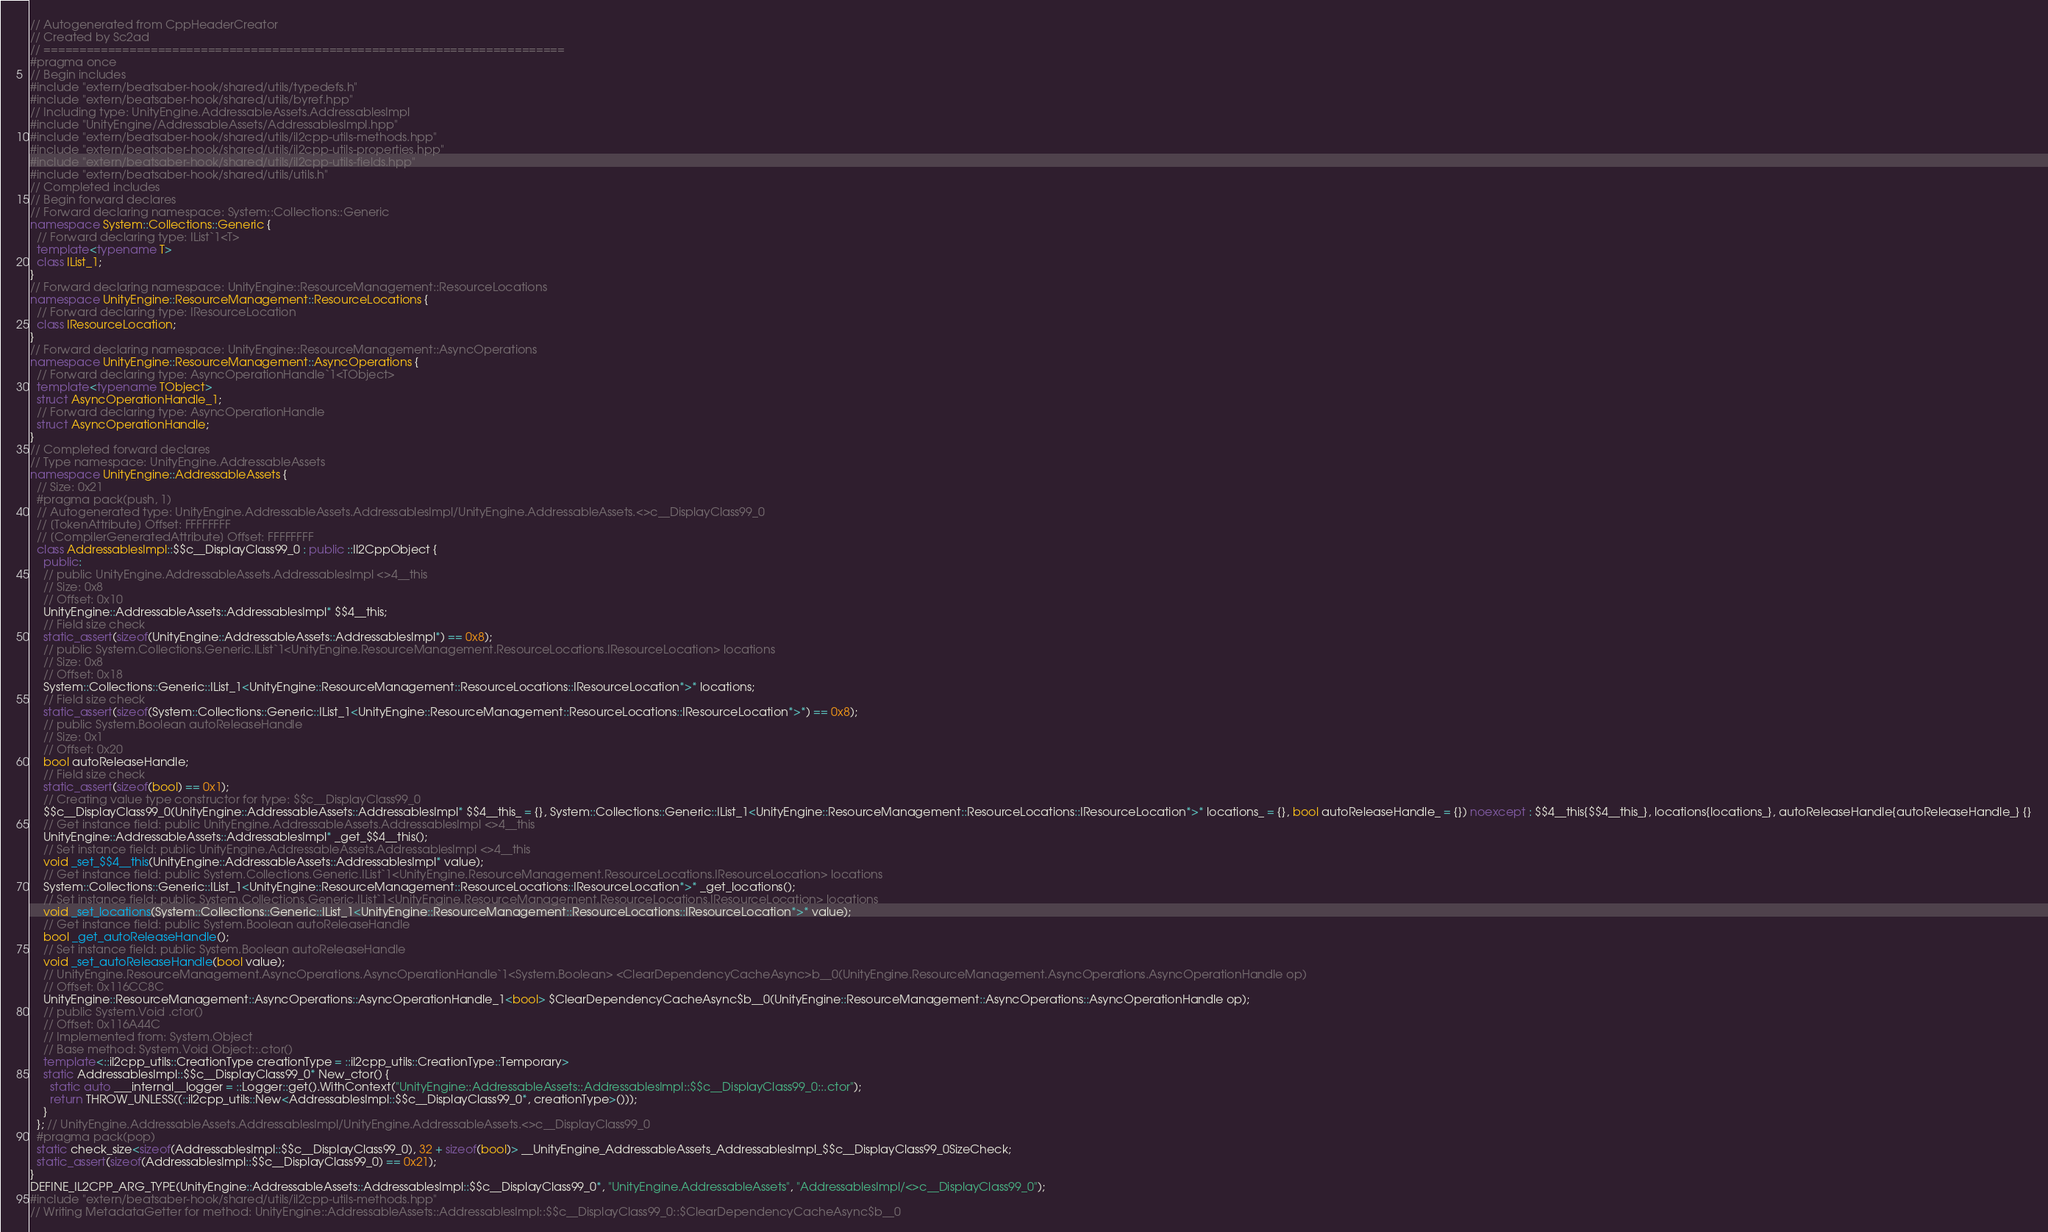Convert code to text. <code><loc_0><loc_0><loc_500><loc_500><_C++_>// Autogenerated from CppHeaderCreator
// Created by Sc2ad
// =========================================================================
#pragma once
// Begin includes
#include "extern/beatsaber-hook/shared/utils/typedefs.h"
#include "extern/beatsaber-hook/shared/utils/byref.hpp"
// Including type: UnityEngine.AddressableAssets.AddressablesImpl
#include "UnityEngine/AddressableAssets/AddressablesImpl.hpp"
#include "extern/beatsaber-hook/shared/utils/il2cpp-utils-methods.hpp"
#include "extern/beatsaber-hook/shared/utils/il2cpp-utils-properties.hpp"
#include "extern/beatsaber-hook/shared/utils/il2cpp-utils-fields.hpp"
#include "extern/beatsaber-hook/shared/utils/utils.h"
// Completed includes
// Begin forward declares
// Forward declaring namespace: System::Collections::Generic
namespace System::Collections::Generic {
  // Forward declaring type: IList`1<T>
  template<typename T>
  class IList_1;
}
// Forward declaring namespace: UnityEngine::ResourceManagement::ResourceLocations
namespace UnityEngine::ResourceManagement::ResourceLocations {
  // Forward declaring type: IResourceLocation
  class IResourceLocation;
}
// Forward declaring namespace: UnityEngine::ResourceManagement::AsyncOperations
namespace UnityEngine::ResourceManagement::AsyncOperations {
  // Forward declaring type: AsyncOperationHandle`1<TObject>
  template<typename TObject>
  struct AsyncOperationHandle_1;
  // Forward declaring type: AsyncOperationHandle
  struct AsyncOperationHandle;
}
// Completed forward declares
// Type namespace: UnityEngine.AddressableAssets
namespace UnityEngine::AddressableAssets {
  // Size: 0x21
  #pragma pack(push, 1)
  // Autogenerated type: UnityEngine.AddressableAssets.AddressablesImpl/UnityEngine.AddressableAssets.<>c__DisplayClass99_0
  // [TokenAttribute] Offset: FFFFFFFF
  // [CompilerGeneratedAttribute] Offset: FFFFFFFF
  class AddressablesImpl::$$c__DisplayClass99_0 : public ::Il2CppObject {
    public:
    // public UnityEngine.AddressableAssets.AddressablesImpl <>4__this
    // Size: 0x8
    // Offset: 0x10
    UnityEngine::AddressableAssets::AddressablesImpl* $$4__this;
    // Field size check
    static_assert(sizeof(UnityEngine::AddressableAssets::AddressablesImpl*) == 0x8);
    // public System.Collections.Generic.IList`1<UnityEngine.ResourceManagement.ResourceLocations.IResourceLocation> locations
    // Size: 0x8
    // Offset: 0x18
    System::Collections::Generic::IList_1<UnityEngine::ResourceManagement::ResourceLocations::IResourceLocation*>* locations;
    // Field size check
    static_assert(sizeof(System::Collections::Generic::IList_1<UnityEngine::ResourceManagement::ResourceLocations::IResourceLocation*>*) == 0x8);
    // public System.Boolean autoReleaseHandle
    // Size: 0x1
    // Offset: 0x20
    bool autoReleaseHandle;
    // Field size check
    static_assert(sizeof(bool) == 0x1);
    // Creating value type constructor for type: $$c__DisplayClass99_0
    $$c__DisplayClass99_0(UnityEngine::AddressableAssets::AddressablesImpl* $$4__this_ = {}, System::Collections::Generic::IList_1<UnityEngine::ResourceManagement::ResourceLocations::IResourceLocation*>* locations_ = {}, bool autoReleaseHandle_ = {}) noexcept : $$4__this{$$4__this_}, locations{locations_}, autoReleaseHandle{autoReleaseHandle_} {}
    // Get instance field: public UnityEngine.AddressableAssets.AddressablesImpl <>4__this
    UnityEngine::AddressableAssets::AddressablesImpl* _get_$$4__this();
    // Set instance field: public UnityEngine.AddressableAssets.AddressablesImpl <>4__this
    void _set_$$4__this(UnityEngine::AddressableAssets::AddressablesImpl* value);
    // Get instance field: public System.Collections.Generic.IList`1<UnityEngine.ResourceManagement.ResourceLocations.IResourceLocation> locations
    System::Collections::Generic::IList_1<UnityEngine::ResourceManagement::ResourceLocations::IResourceLocation*>* _get_locations();
    // Set instance field: public System.Collections.Generic.IList`1<UnityEngine.ResourceManagement.ResourceLocations.IResourceLocation> locations
    void _set_locations(System::Collections::Generic::IList_1<UnityEngine::ResourceManagement::ResourceLocations::IResourceLocation*>* value);
    // Get instance field: public System.Boolean autoReleaseHandle
    bool _get_autoReleaseHandle();
    // Set instance field: public System.Boolean autoReleaseHandle
    void _set_autoReleaseHandle(bool value);
    // UnityEngine.ResourceManagement.AsyncOperations.AsyncOperationHandle`1<System.Boolean> <ClearDependencyCacheAsync>b__0(UnityEngine.ResourceManagement.AsyncOperations.AsyncOperationHandle op)
    // Offset: 0x116CC8C
    UnityEngine::ResourceManagement::AsyncOperations::AsyncOperationHandle_1<bool> $ClearDependencyCacheAsync$b__0(UnityEngine::ResourceManagement::AsyncOperations::AsyncOperationHandle op);
    // public System.Void .ctor()
    // Offset: 0x116A44C
    // Implemented from: System.Object
    // Base method: System.Void Object::.ctor()
    template<::il2cpp_utils::CreationType creationType = ::il2cpp_utils::CreationType::Temporary>
    static AddressablesImpl::$$c__DisplayClass99_0* New_ctor() {
      static auto ___internal__logger = ::Logger::get().WithContext("UnityEngine::AddressableAssets::AddressablesImpl::$$c__DisplayClass99_0::.ctor");
      return THROW_UNLESS((::il2cpp_utils::New<AddressablesImpl::$$c__DisplayClass99_0*, creationType>()));
    }
  }; // UnityEngine.AddressableAssets.AddressablesImpl/UnityEngine.AddressableAssets.<>c__DisplayClass99_0
  #pragma pack(pop)
  static check_size<sizeof(AddressablesImpl::$$c__DisplayClass99_0), 32 + sizeof(bool)> __UnityEngine_AddressableAssets_AddressablesImpl_$$c__DisplayClass99_0SizeCheck;
  static_assert(sizeof(AddressablesImpl::$$c__DisplayClass99_0) == 0x21);
}
DEFINE_IL2CPP_ARG_TYPE(UnityEngine::AddressableAssets::AddressablesImpl::$$c__DisplayClass99_0*, "UnityEngine.AddressableAssets", "AddressablesImpl/<>c__DisplayClass99_0");
#include "extern/beatsaber-hook/shared/utils/il2cpp-utils-methods.hpp"
// Writing MetadataGetter for method: UnityEngine::AddressableAssets::AddressablesImpl::$$c__DisplayClass99_0::$ClearDependencyCacheAsync$b__0</code> 